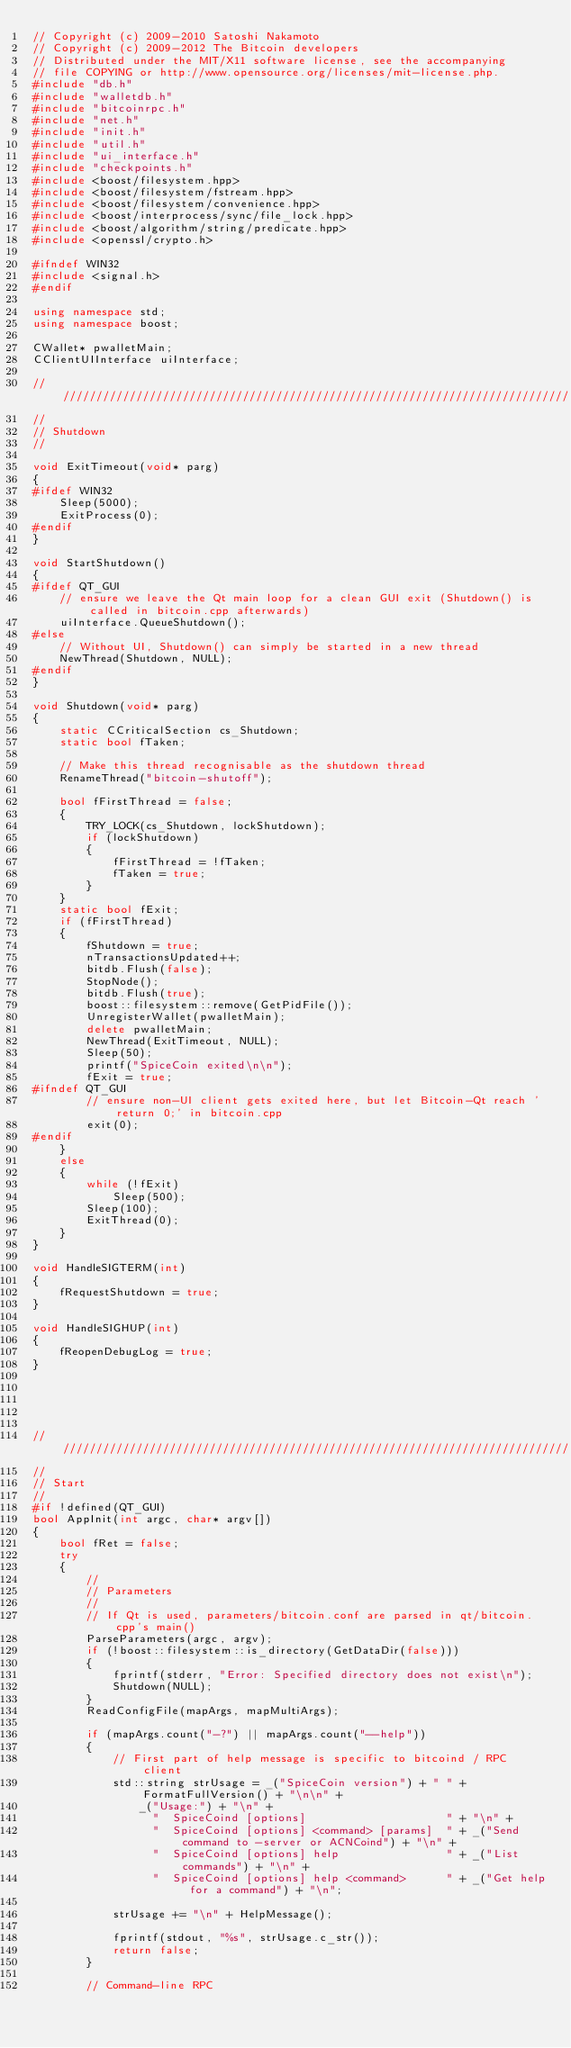Convert code to text. <code><loc_0><loc_0><loc_500><loc_500><_C++_>// Copyright (c) 2009-2010 Satoshi Nakamoto
// Copyright (c) 2009-2012 The Bitcoin developers
// Distributed under the MIT/X11 software license, see the accompanying
// file COPYING or http://www.opensource.org/licenses/mit-license.php.
#include "db.h"
#include "walletdb.h"
#include "bitcoinrpc.h"
#include "net.h"
#include "init.h"
#include "util.h"
#include "ui_interface.h"
#include "checkpoints.h"
#include <boost/filesystem.hpp>
#include <boost/filesystem/fstream.hpp>
#include <boost/filesystem/convenience.hpp>
#include <boost/interprocess/sync/file_lock.hpp>
#include <boost/algorithm/string/predicate.hpp>
#include <openssl/crypto.h>

#ifndef WIN32
#include <signal.h>
#endif

using namespace std;
using namespace boost;

CWallet* pwalletMain;
CClientUIInterface uiInterface;

//////////////////////////////////////////////////////////////////////////////
//
// Shutdown
//

void ExitTimeout(void* parg)
{
#ifdef WIN32
    Sleep(5000);
    ExitProcess(0);
#endif
}

void StartShutdown()
{
#ifdef QT_GUI
    // ensure we leave the Qt main loop for a clean GUI exit (Shutdown() is called in bitcoin.cpp afterwards)
    uiInterface.QueueShutdown();
#else
    // Without UI, Shutdown() can simply be started in a new thread
    NewThread(Shutdown, NULL);
#endif
}

void Shutdown(void* parg)
{
    static CCriticalSection cs_Shutdown;
    static bool fTaken;

    // Make this thread recognisable as the shutdown thread
    RenameThread("bitcoin-shutoff");

    bool fFirstThread = false;
    {
        TRY_LOCK(cs_Shutdown, lockShutdown);
        if (lockShutdown)
        {
            fFirstThread = !fTaken;
            fTaken = true;
        }
    }
    static bool fExit;
    if (fFirstThread)
    {
        fShutdown = true;
        nTransactionsUpdated++;
        bitdb.Flush(false);
        StopNode();
        bitdb.Flush(true);
        boost::filesystem::remove(GetPidFile());
        UnregisterWallet(pwalletMain);
        delete pwalletMain;
        NewThread(ExitTimeout, NULL);
        Sleep(50);
        printf("SpiceCoin exited\n\n");
        fExit = true;
#ifndef QT_GUI
        // ensure non-UI client gets exited here, but let Bitcoin-Qt reach 'return 0;' in bitcoin.cpp
        exit(0);
#endif
    }
    else
    {
        while (!fExit)
            Sleep(500);
        Sleep(100);
        ExitThread(0);
    }
}

void HandleSIGTERM(int)
{
    fRequestShutdown = true;
}

void HandleSIGHUP(int)
{
    fReopenDebugLog = true;
}





//////////////////////////////////////////////////////////////////////////////
//
// Start
//
#if !defined(QT_GUI)
bool AppInit(int argc, char* argv[])
{
    bool fRet = false;
    try
    {
        //
        // Parameters
        //
        // If Qt is used, parameters/bitcoin.conf are parsed in qt/bitcoin.cpp's main()
        ParseParameters(argc, argv);
        if (!boost::filesystem::is_directory(GetDataDir(false)))
        {
            fprintf(stderr, "Error: Specified directory does not exist\n");
            Shutdown(NULL);
        }
        ReadConfigFile(mapArgs, mapMultiArgs);

        if (mapArgs.count("-?") || mapArgs.count("--help"))
        {
            // First part of help message is specific to bitcoind / RPC client
            std::string strUsage = _("SpiceCoin version") + " " + FormatFullVersion() + "\n\n" +
                _("Usage:") + "\n" +
                  "  SpiceCoind [options]                     " + "\n" +
                  "  SpiceCoind [options] <command> [params]  " + _("Send command to -server or ACNCoind") + "\n" +
                  "  SpiceCoind [options] help                " + _("List commands") + "\n" +
                  "  SpiceCoind [options] help <command>      " + _("Get help for a command") + "\n";

            strUsage += "\n" + HelpMessage();

            fprintf(stdout, "%s", strUsage.c_str());
            return false;
        }

        // Command-line RPC</code> 